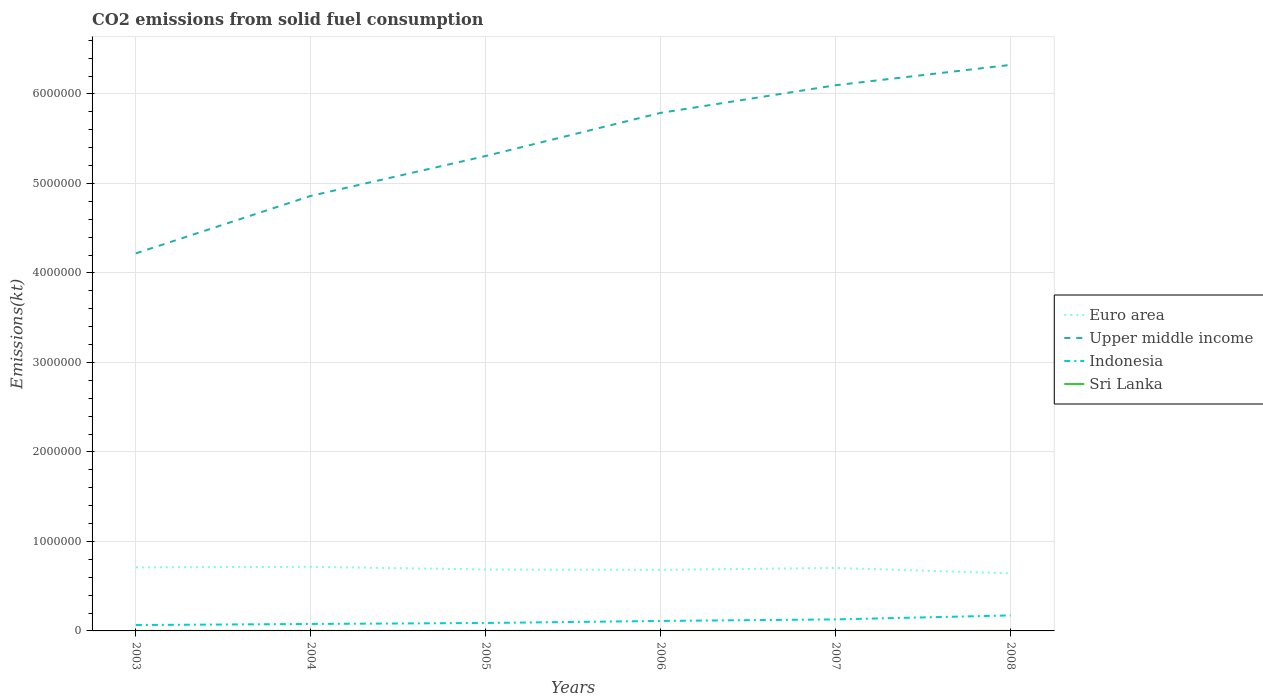How many different coloured lines are there?
Keep it short and to the point. 4. Across all years, what is the maximum amount of CO2 emitted in Indonesia?
Provide a succinct answer. 6.58e+04. In which year was the amount of CO2 emitted in Sri Lanka maximum?
Offer a very short reply. 2007. What is the total amount of CO2 emitted in Sri Lanka in the graph?
Your answer should be very brief. 0. What is the difference between the highest and the second highest amount of CO2 emitted in Euro area?
Make the answer very short. 7.28e+04. What is the difference between the highest and the lowest amount of CO2 emitted in Euro area?
Offer a terse response. 3. How many lines are there?
Provide a succinct answer. 4. Does the graph contain any zero values?
Make the answer very short. No. Does the graph contain grids?
Keep it short and to the point. Yes. Where does the legend appear in the graph?
Keep it short and to the point. Center right. How are the legend labels stacked?
Your answer should be compact. Vertical. What is the title of the graph?
Offer a terse response. CO2 emissions from solid fuel consumption. Does "Iran" appear as one of the legend labels in the graph?
Offer a terse response. No. What is the label or title of the X-axis?
Your answer should be very brief. Years. What is the label or title of the Y-axis?
Your answer should be compact. Emissions(kt). What is the Emissions(kt) of Euro area in 2003?
Give a very brief answer. 7.10e+05. What is the Emissions(kt) of Upper middle income in 2003?
Ensure brevity in your answer.  4.22e+06. What is the Emissions(kt) in Indonesia in 2003?
Your response must be concise. 6.58e+04. What is the Emissions(kt) of Sri Lanka in 2003?
Provide a succinct answer. 231.02. What is the Emissions(kt) in Euro area in 2004?
Provide a succinct answer. 7.16e+05. What is the Emissions(kt) of Upper middle income in 2004?
Provide a short and direct response. 4.86e+06. What is the Emissions(kt) of Indonesia in 2004?
Offer a very short reply. 7.77e+04. What is the Emissions(kt) in Sri Lanka in 2004?
Make the answer very short. 231.02. What is the Emissions(kt) of Euro area in 2005?
Offer a very short reply. 6.86e+05. What is the Emissions(kt) of Upper middle income in 2005?
Provide a succinct answer. 5.31e+06. What is the Emissions(kt) of Indonesia in 2005?
Ensure brevity in your answer.  8.86e+04. What is the Emissions(kt) in Sri Lanka in 2005?
Ensure brevity in your answer.  231.02. What is the Emissions(kt) of Euro area in 2006?
Offer a very short reply. 6.82e+05. What is the Emissions(kt) in Upper middle income in 2006?
Offer a terse response. 5.79e+06. What is the Emissions(kt) in Indonesia in 2006?
Offer a very short reply. 1.11e+05. What is the Emissions(kt) of Sri Lanka in 2006?
Keep it short and to the point. 227.35. What is the Emissions(kt) of Euro area in 2007?
Offer a terse response. 7.04e+05. What is the Emissions(kt) of Upper middle income in 2007?
Your response must be concise. 6.10e+06. What is the Emissions(kt) in Indonesia in 2007?
Your response must be concise. 1.29e+05. What is the Emissions(kt) of Sri Lanka in 2007?
Your response must be concise. 161.35. What is the Emissions(kt) of Euro area in 2008?
Make the answer very short. 6.44e+05. What is the Emissions(kt) in Upper middle income in 2008?
Make the answer very short. 6.32e+06. What is the Emissions(kt) of Indonesia in 2008?
Ensure brevity in your answer.  1.73e+05. What is the Emissions(kt) of Sri Lanka in 2008?
Ensure brevity in your answer.  220.02. Across all years, what is the maximum Emissions(kt) of Euro area?
Your answer should be very brief. 7.16e+05. Across all years, what is the maximum Emissions(kt) in Upper middle income?
Your response must be concise. 6.32e+06. Across all years, what is the maximum Emissions(kt) of Indonesia?
Offer a terse response. 1.73e+05. Across all years, what is the maximum Emissions(kt) of Sri Lanka?
Give a very brief answer. 231.02. Across all years, what is the minimum Emissions(kt) in Euro area?
Your answer should be very brief. 6.44e+05. Across all years, what is the minimum Emissions(kt) in Upper middle income?
Offer a terse response. 4.22e+06. Across all years, what is the minimum Emissions(kt) of Indonesia?
Your answer should be compact. 6.58e+04. Across all years, what is the minimum Emissions(kt) in Sri Lanka?
Make the answer very short. 161.35. What is the total Emissions(kt) in Euro area in the graph?
Keep it short and to the point. 4.14e+06. What is the total Emissions(kt) in Upper middle income in the graph?
Offer a terse response. 3.26e+07. What is the total Emissions(kt) in Indonesia in the graph?
Your answer should be very brief. 6.46e+05. What is the total Emissions(kt) of Sri Lanka in the graph?
Your answer should be compact. 1301.79. What is the difference between the Emissions(kt) of Euro area in 2003 and that in 2004?
Your response must be concise. -6039.27. What is the difference between the Emissions(kt) in Upper middle income in 2003 and that in 2004?
Offer a terse response. -6.42e+05. What is the difference between the Emissions(kt) of Indonesia in 2003 and that in 2004?
Offer a terse response. -1.20e+04. What is the difference between the Emissions(kt) in Euro area in 2003 and that in 2005?
Offer a terse response. 2.40e+04. What is the difference between the Emissions(kt) of Upper middle income in 2003 and that in 2005?
Your answer should be very brief. -1.09e+06. What is the difference between the Emissions(kt) of Indonesia in 2003 and that in 2005?
Provide a short and direct response. -2.29e+04. What is the difference between the Emissions(kt) in Sri Lanka in 2003 and that in 2005?
Offer a terse response. 0. What is the difference between the Emissions(kt) in Euro area in 2003 and that in 2006?
Provide a short and direct response. 2.78e+04. What is the difference between the Emissions(kt) of Upper middle income in 2003 and that in 2006?
Keep it short and to the point. -1.57e+06. What is the difference between the Emissions(kt) of Indonesia in 2003 and that in 2006?
Give a very brief answer. -4.57e+04. What is the difference between the Emissions(kt) in Sri Lanka in 2003 and that in 2006?
Give a very brief answer. 3.67. What is the difference between the Emissions(kt) in Euro area in 2003 and that in 2007?
Offer a very short reply. 6607.98. What is the difference between the Emissions(kt) of Upper middle income in 2003 and that in 2007?
Keep it short and to the point. -1.88e+06. What is the difference between the Emissions(kt) of Indonesia in 2003 and that in 2007?
Provide a succinct answer. -6.30e+04. What is the difference between the Emissions(kt) in Sri Lanka in 2003 and that in 2007?
Keep it short and to the point. 69.67. What is the difference between the Emissions(kt) of Euro area in 2003 and that in 2008?
Provide a succinct answer. 6.67e+04. What is the difference between the Emissions(kt) of Upper middle income in 2003 and that in 2008?
Ensure brevity in your answer.  -2.11e+06. What is the difference between the Emissions(kt) in Indonesia in 2003 and that in 2008?
Provide a succinct answer. -1.07e+05. What is the difference between the Emissions(kt) in Sri Lanka in 2003 and that in 2008?
Offer a very short reply. 11. What is the difference between the Emissions(kt) of Euro area in 2004 and that in 2005?
Give a very brief answer. 3.00e+04. What is the difference between the Emissions(kt) of Upper middle income in 2004 and that in 2005?
Your answer should be very brief. -4.45e+05. What is the difference between the Emissions(kt) of Indonesia in 2004 and that in 2005?
Keep it short and to the point. -1.09e+04. What is the difference between the Emissions(kt) of Euro area in 2004 and that in 2006?
Offer a very short reply. 3.39e+04. What is the difference between the Emissions(kt) of Upper middle income in 2004 and that in 2006?
Offer a very short reply. -9.28e+05. What is the difference between the Emissions(kt) in Indonesia in 2004 and that in 2006?
Offer a very short reply. -3.37e+04. What is the difference between the Emissions(kt) in Sri Lanka in 2004 and that in 2006?
Keep it short and to the point. 3.67. What is the difference between the Emissions(kt) of Euro area in 2004 and that in 2007?
Provide a succinct answer. 1.26e+04. What is the difference between the Emissions(kt) in Upper middle income in 2004 and that in 2007?
Offer a very short reply. -1.24e+06. What is the difference between the Emissions(kt) in Indonesia in 2004 and that in 2007?
Provide a succinct answer. -5.10e+04. What is the difference between the Emissions(kt) in Sri Lanka in 2004 and that in 2007?
Give a very brief answer. 69.67. What is the difference between the Emissions(kt) of Euro area in 2004 and that in 2008?
Offer a very short reply. 7.28e+04. What is the difference between the Emissions(kt) in Upper middle income in 2004 and that in 2008?
Your answer should be compact. -1.46e+06. What is the difference between the Emissions(kt) of Indonesia in 2004 and that in 2008?
Your response must be concise. -9.55e+04. What is the difference between the Emissions(kt) in Sri Lanka in 2004 and that in 2008?
Ensure brevity in your answer.  11. What is the difference between the Emissions(kt) in Euro area in 2005 and that in 2006?
Give a very brief answer. 3892.87. What is the difference between the Emissions(kt) in Upper middle income in 2005 and that in 2006?
Your answer should be very brief. -4.82e+05. What is the difference between the Emissions(kt) of Indonesia in 2005 and that in 2006?
Make the answer very short. -2.28e+04. What is the difference between the Emissions(kt) in Sri Lanka in 2005 and that in 2006?
Provide a short and direct response. 3.67. What is the difference between the Emissions(kt) in Euro area in 2005 and that in 2007?
Your answer should be compact. -1.73e+04. What is the difference between the Emissions(kt) in Upper middle income in 2005 and that in 2007?
Give a very brief answer. -7.91e+05. What is the difference between the Emissions(kt) of Indonesia in 2005 and that in 2007?
Keep it short and to the point. -4.01e+04. What is the difference between the Emissions(kt) in Sri Lanka in 2005 and that in 2007?
Offer a very short reply. 69.67. What is the difference between the Emissions(kt) of Euro area in 2005 and that in 2008?
Ensure brevity in your answer.  4.28e+04. What is the difference between the Emissions(kt) of Upper middle income in 2005 and that in 2008?
Offer a terse response. -1.02e+06. What is the difference between the Emissions(kt) of Indonesia in 2005 and that in 2008?
Ensure brevity in your answer.  -8.46e+04. What is the difference between the Emissions(kt) in Sri Lanka in 2005 and that in 2008?
Your response must be concise. 11. What is the difference between the Emissions(kt) of Euro area in 2006 and that in 2007?
Your response must be concise. -2.12e+04. What is the difference between the Emissions(kt) in Upper middle income in 2006 and that in 2007?
Your answer should be compact. -3.08e+05. What is the difference between the Emissions(kt) of Indonesia in 2006 and that in 2007?
Ensure brevity in your answer.  -1.73e+04. What is the difference between the Emissions(kt) in Sri Lanka in 2006 and that in 2007?
Make the answer very short. 66.01. What is the difference between the Emissions(kt) in Euro area in 2006 and that in 2008?
Give a very brief answer. 3.89e+04. What is the difference between the Emissions(kt) of Upper middle income in 2006 and that in 2008?
Give a very brief answer. -5.36e+05. What is the difference between the Emissions(kt) of Indonesia in 2006 and that in 2008?
Give a very brief answer. -6.18e+04. What is the difference between the Emissions(kt) in Sri Lanka in 2006 and that in 2008?
Provide a succinct answer. 7.33. What is the difference between the Emissions(kt) of Euro area in 2007 and that in 2008?
Make the answer very short. 6.01e+04. What is the difference between the Emissions(kt) in Upper middle income in 2007 and that in 2008?
Provide a short and direct response. -2.28e+05. What is the difference between the Emissions(kt) of Indonesia in 2007 and that in 2008?
Your answer should be compact. -4.45e+04. What is the difference between the Emissions(kt) in Sri Lanka in 2007 and that in 2008?
Ensure brevity in your answer.  -58.67. What is the difference between the Emissions(kt) in Euro area in 2003 and the Emissions(kt) in Upper middle income in 2004?
Your response must be concise. -4.15e+06. What is the difference between the Emissions(kt) of Euro area in 2003 and the Emissions(kt) of Indonesia in 2004?
Your response must be concise. 6.33e+05. What is the difference between the Emissions(kt) in Euro area in 2003 and the Emissions(kt) in Sri Lanka in 2004?
Give a very brief answer. 7.10e+05. What is the difference between the Emissions(kt) of Upper middle income in 2003 and the Emissions(kt) of Indonesia in 2004?
Your answer should be compact. 4.14e+06. What is the difference between the Emissions(kt) of Upper middle income in 2003 and the Emissions(kt) of Sri Lanka in 2004?
Your answer should be compact. 4.22e+06. What is the difference between the Emissions(kt) of Indonesia in 2003 and the Emissions(kt) of Sri Lanka in 2004?
Provide a short and direct response. 6.55e+04. What is the difference between the Emissions(kt) in Euro area in 2003 and the Emissions(kt) in Upper middle income in 2005?
Your answer should be compact. -4.60e+06. What is the difference between the Emissions(kt) in Euro area in 2003 and the Emissions(kt) in Indonesia in 2005?
Offer a very short reply. 6.22e+05. What is the difference between the Emissions(kt) in Euro area in 2003 and the Emissions(kt) in Sri Lanka in 2005?
Your answer should be very brief. 7.10e+05. What is the difference between the Emissions(kt) of Upper middle income in 2003 and the Emissions(kt) of Indonesia in 2005?
Ensure brevity in your answer.  4.13e+06. What is the difference between the Emissions(kt) in Upper middle income in 2003 and the Emissions(kt) in Sri Lanka in 2005?
Provide a short and direct response. 4.22e+06. What is the difference between the Emissions(kt) in Indonesia in 2003 and the Emissions(kt) in Sri Lanka in 2005?
Offer a very short reply. 6.55e+04. What is the difference between the Emissions(kt) in Euro area in 2003 and the Emissions(kt) in Upper middle income in 2006?
Give a very brief answer. -5.08e+06. What is the difference between the Emissions(kt) in Euro area in 2003 and the Emissions(kt) in Indonesia in 2006?
Your answer should be compact. 5.99e+05. What is the difference between the Emissions(kt) in Euro area in 2003 and the Emissions(kt) in Sri Lanka in 2006?
Your response must be concise. 7.10e+05. What is the difference between the Emissions(kt) of Upper middle income in 2003 and the Emissions(kt) of Indonesia in 2006?
Your answer should be very brief. 4.11e+06. What is the difference between the Emissions(kt) of Upper middle income in 2003 and the Emissions(kt) of Sri Lanka in 2006?
Your response must be concise. 4.22e+06. What is the difference between the Emissions(kt) in Indonesia in 2003 and the Emissions(kt) in Sri Lanka in 2006?
Make the answer very short. 6.55e+04. What is the difference between the Emissions(kt) in Euro area in 2003 and the Emissions(kt) in Upper middle income in 2007?
Ensure brevity in your answer.  -5.39e+06. What is the difference between the Emissions(kt) in Euro area in 2003 and the Emissions(kt) in Indonesia in 2007?
Keep it short and to the point. 5.81e+05. What is the difference between the Emissions(kt) of Euro area in 2003 and the Emissions(kt) of Sri Lanka in 2007?
Keep it short and to the point. 7.10e+05. What is the difference between the Emissions(kt) in Upper middle income in 2003 and the Emissions(kt) in Indonesia in 2007?
Offer a terse response. 4.09e+06. What is the difference between the Emissions(kt) in Upper middle income in 2003 and the Emissions(kt) in Sri Lanka in 2007?
Provide a short and direct response. 4.22e+06. What is the difference between the Emissions(kt) of Indonesia in 2003 and the Emissions(kt) of Sri Lanka in 2007?
Ensure brevity in your answer.  6.56e+04. What is the difference between the Emissions(kt) in Euro area in 2003 and the Emissions(kt) in Upper middle income in 2008?
Provide a succinct answer. -5.61e+06. What is the difference between the Emissions(kt) in Euro area in 2003 and the Emissions(kt) in Indonesia in 2008?
Offer a very short reply. 5.37e+05. What is the difference between the Emissions(kt) of Euro area in 2003 and the Emissions(kt) of Sri Lanka in 2008?
Give a very brief answer. 7.10e+05. What is the difference between the Emissions(kt) in Upper middle income in 2003 and the Emissions(kt) in Indonesia in 2008?
Keep it short and to the point. 4.05e+06. What is the difference between the Emissions(kt) in Upper middle income in 2003 and the Emissions(kt) in Sri Lanka in 2008?
Offer a terse response. 4.22e+06. What is the difference between the Emissions(kt) of Indonesia in 2003 and the Emissions(kt) of Sri Lanka in 2008?
Provide a succinct answer. 6.55e+04. What is the difference between the Emissions(kt) of Euro area in 2004 and the Emissions(kt) of Upper middle income in 2005?
Give a very brief answer. -4.59e+06. What is the difference between the Emissions(kt) of Euro area in 2004 and the Emissions(kt) of Indonesia in 2005?
Make the answer very short. 6.28e+05. What is the difference between the Emissions(kt) in Euro area in 2004 and the Emissions(kt) in Sri Lanka in 2005?
Your answer should be very brief. 7.16e+05. What is the difference between the Emissions(kt) of Upper middle income in 2004 and the Emissions(kt) of Indonesia in 2005?
Offer a very short reply. 4.77e+06. What is the difference between the Emissions(kt) in Upper middle income in 2004 and the Emissions(kt) in Sri Lanka in 2005?
Offer a terse response. 4.86e+06. What is the difference between the Emissions(kt) of Indonesia in 2004 and the Emissions(kt) of Sri Lanka in 2005?
Make the answer very short. 7.75e+04. What is the difference between the Emissions(kt) in Euro area in 2004 and the Emissions(kt) in Upper middle income in 2006?
Offer a terse response. -5.07e+06. What is the difference between the Emissions(kt) in Euro area in 2004 and the Emissions(kt) in Indonesia in 2006?
Keep it short and to the point. 6.05e+05. What is the difference between the Emissions(kt) of Euro area in 2004 and the Emissions(kt) of Sri Lanka in 2006?
Provide a short and direct response. 7.16e+05. What is the difference between the Emissions(kt) of Upper middle income in 2004 and the Emissions(kt) of Indonesia in 2006?
Your answer should be very brief. 4.75e+06. What is the difference between the Emissions(kt) in Upper middle income in 2004 and the Emissions(kt) in Sri Lanka in 2006?
Provide a short and direct response. 4.86e+06. What is the difference between the Emissions(kt) in Indonesia in 2004 and the Emissions(kt) in Sri Lanka in 2006?
Offer a terse response. 7.75e+04. What is the difference between the Emissions(kt) in Euro area in 2004 and the Emissions(kt) in Upper middle income in 2007?
Your answer should be compact. -5.38e+06. What is the difference between the Emissions(kt) of Euro area in 2004 and the Emissions(kt) of Indonesia in 2007?
Make the answer very short. 5.88e+05. What is the difference between the Emissions(kt) in Euro area in 2004 and the Emissions(kt) in Sri Lanka in 2007?
Your answer should be compact. 7.16e+05. What is the difference between the Emissions(kt) of Upper middle income in 2004 and the Emissions(kt) of Indonesia in 2007?
Your response must be concise. 4.73e+06. What is the difference between the Emissions(kt) in Upper middle income in 2004 and the Emissions(kt) in Sri Lanka in 2007?
Your answer should be very brief. 4.86e+06. What is the difference between the Emissions(kt) of Indonesia in 2004 and the Emissions(kt) of Sri Lanka in 2007?
Provide a short and direct response. 7.76e+04. What is the difference between the Emissions(kt) in Euro area in 2004 and the Emissions(kt) in Upper middle income in 2008?
Keep it short and to the point. -5.61e+06. What is the difference between the Emissions(kt) in Euro area in 2004 and the Emissions(kt) in Indonesia in 2008?
Give a very brief answer. 5.43e+05. What is the difference between the Emissions(kt) in Euro area in 2004 and the Emissions(kt) in Sri Lanka in 2008?
Offer a very short reply. 7.16e+05. What is the difference between the Emissions(kt) of Upper middle income in 2004 and the Emissions(kt) of Indonesia in 2008?
Make the answer very short. 4.69e+06. What is the difference between the Emissions(kt) of Upper middle income in 2004 and the Emissions(kt) of Sri Lanka in 2008?
Provide a short and direct response. 4.86e+06. What is the difference between the Emissions(kt) of Indonesia in 2004 and the Emissions(kt) of Sri Lanka in 2008?
Offer a very short reply. 7.75e+04. What is the difference between the Emissions(kt) in Euro area in 2005 and the Emissions(kt) in Upper middle income in 2006?
Your response must be concise. -5.10e+06. What is the difference between the Emissions(kt) in Euro area in 2005 and the Emissions(kt) in Indonesia in 2006?
Your response must be concise. 5.75e+05. What is the difference between the Emissions(kt) of Euro area in 2005 and the Emissions(kt) of Sri Lanka in 2006?
Give a very brief answer. 6.86e+05. What is the difference between the Emissions(kt) in Upper middle income in 2005 and the Emissions(kt) in Indonesia in 2006?
Provide a succinct answer. 5.19e+06. What is the difference between the Emissions(kt) in Upper middle income in 2005 and the Emissions(kt) in Sri Lanka in 2006?
Provide a succinct answer. 5.31e+06. What is the difference between the Emissions(kt) of Indonesia in 2005 and the Emissions(kt) of Sri Lanka in 2006?
Make the answer very short. 8.84e+04. What is the difference between the Emissions(kt) of Euro area in 2005 and the Emissions(kt) of Upper middle income in 2007?
Offer a very short reply. -5.41e+06. What is the difference between the Emissions(kt) of Euro area in 2005 and the Emissions(kt) of Indonesia in 2007?
Your answer should be compact. 5.58e+05. What is the difference between the Emissions(kt) of Euro area in 2005 and the Emissions(kt) of Sri Lanka in 2007?
Your answer should be compact. 6.86e+05. What is the difference between the Emissions(kt) of Upper middle income in 2005 and the Emissions(kt) of Indonesia in 2007?
Keep it short and to the point. 5.18e+06. What is the difference between the Emissions(kt) in Upper middle income in 2005 and the Emissions(kt) in Sri Lanka in 2007?
Make the answer very short. 5.31e+06. What is the difference between the Emissions(kt) of Indonesia in 2005 and the Emissions(kt) of Sri Lanka in 2007?
Make the answer very short. 8.85e+04. What is the difference between the Emissions(kt) of Euro area in 2005 and the Emissions(kt) of Upper middle income in 2008?
Make the answer very short. -5.64e+06. What is the difference between the Emissions(kt) in Euro area in 2005 and the Emissions(kt) in Indonesia in 2008?
Your answer should be very brief. 5.13e+05. What is the difference between the Emissions(kt) in Euro area in 2005 and the Emissions(kt) in Sri Lanka in 2008?
Offer a very short reply. 6.86e+05. What is the difference between the Emissions(kt) of Upper middle income in 2005 and the Emissions(kt) of Indonesia in 2008?
Make the answer very short. 5.13e+06. What is the difference between the Emissions(kt) of Upper middle income in 2005 and the Emissions(kt) of Sri Lanka in 2008?
Provide a succinct answer. 5.31e+06. What is the difference between the Emissions(kt) in Indonesia in 2005 and the Emissions(kt) in Sri Lanka in 2008?
Offer a terse response. 8.84e+04. What is the difference between the Emissions(kt) in Euro area in 2006 and the Emissions(kt) in Upper middle income in 2007?
Keep it short and to the point. -5.41e+06. What is the difference between the Emissions(kt) in Euro area in 2006 and the Emissions(kt) in Indonesia in 2007?
Offer a terse response. 5.54e+05. What is the difference between the Emissions(kt) of Euro area in 2006 and the Emissions(kt) of Sri Lanka in 2007?
Keep it short and to the point. 6.82e+05. What is the difference between the Emissions(kt) of Upper middle income in 2006 and the Emissions(kt) of Indonesia in 2007?
Your answer should be very brief. 5.66e+06. What is the difference between the Emissions(kt) of Upper middle income in 2006 and the Emissions(kt) of Sri Lanka in 2007?
Ensure brevity in your answer.  5.79e+06. What is the difference between the Emissions(kt) of Indonesia in 2006 and the Emissions(kt) of Sri Lanka in 2007?
Your answer should be very brief. 1.11e+05. What is the difference between the Emissions(kt) in Euro area in 2006 and the Emissions(kt) in Upper middle income in 2008?
Your response must be concise. -5.64e+06. What is the difference between the Emissions(kt) in Euro area in 2006 and the Emissions(kt) in Indonesia in 2008?
Keep it short and to the point. 5.09e+05. What is the difference between the Emissions(kt) of Euro area in 2006 and the Emissions(kt) of Sri Lanka in 2008?
Provide a short and direct response. 6.82e+05. What is the difference between the Emissions(kt) in Upper middle income in 2006 and the Emissions(kt) in Indonesia in 2008?
Provide a short and direct response. 5.61e+06. What is the difference between the Emissions(kt) of Upper middle income in 2006 and the Emissions(kt) of Sri Lanka in 2008?
Your answer should be very brief. 5.79e+06. What is the difference between the Emissions(kt) of Indonesia in 2006 and the Emissions(kt) of Sri Lanka in 2008?
Your response must be concise. 1.11e+05. What is the difference between the Emissions(kt) of Euro area in 2007 and the Emissions(kt) of Upper middle income in 2008?
Offer a terse response. -5.62e+06. What is the difference between the Emissions(kt) in Euro area in 2007 and the Emissions(kt) in Indonesia in 2008?
Offer a terse response. 5.30e+05. What is the difference between the Emissions(kt) in Euro area in 2007 and the Emissions(kt) in Sri Lanka in 2008?
Keep it short and to the point. 7.03e+05. What is the difference between the Emissions(kt) in Upper middle income in 2007 and the Emissions(kt) in Indonesia in 2008?
Provide a succinct answer. 5.92e+06. What is the difference between the Emissions(kt) of Upper middle income in 2007 and the Emissions(kt) of Sri Lanka in 2008?
Your response must be concise. 6.10e+06. What is the difference between the Emissions(kt) of Indonesia in 2007 and the Emissions(kt) of Sri Lanka in 2008?
Give a very brief answer. 1.29e+05. What is the average Emissions(kt) in Euro area per year?
Your response must be concise. 6.90e+05. What is the average Emissions(kt) in Upper middle income per year?
Your response must be concise. 5.43e+06. What is the average Emissions(kt) of Indonesia per year?
Your response must be concise. 1.08e+05. What is the average Emissions(kt) of Sri Lanka per year?
Your answer should be very brief. 216.96. In the year 2003, what is the difference between the Emissions(kt) in Euro area and Emissions(kt) in Upper middle income?
Your answer should be compact. -3.51e+06. In the year 2003, what is the difference between the Emissions(kt) of Euro area and Emissions(kt) of Indonesia?
Provide a succinct answer. 6.45e+05. In the year 2003, what is the difference between the Emissions(kt) in Euro area and Emissions(kt) in Sri Lanka?
Provide a succinct answer. 7.10e+05. In the year 2003, what is the difference between the Emissions(kt) of Upper middle income and Emissions(kt) of Indonesia?
Your answer should be very brief. 4.15e+06. In the year 2003, what is the difference between the Emissions(kt) of Upper middle income and Emissions(kt) of Sri Lanka?
Your answer should be compact. 4.22e+06. In the year 2003, what is the difference between the Emissions(kt) in Indonesia and Emissions(kt) in Sri Lanka?
Your answer should be very brief. 6.55e+04. In the year 2004, what is the difference between the Emissions(kt) of Euro area and Emissions(kt) of Upper middle income?
Provide a short and direct response. -4.14e+06. In the year 2004, what is the difference between the Emissions(kt) of Euro area and Emissions(kt) of Indonesia?
Offer a very short reply. 6.39e+05. In the year 2004, what is the difference between the Emissions(kt) of Euro area and Emissions(kt) of Sri Lanka?
Keep it short and to the point. 7.16e+05. In the year 2004, what is the difference between the Emissions(kt) of Upper middle income and Emissions(kt) of Indonesia?
Make the answer very short. 4.78e+06. In the year 2004, what is the difference between the Emissions(kt) of Upper middle income and Emissions(kt) of Sri Lanka?
Your response must be concise. 4.86e+06. In the year 2004, what is the difference between the Emissions(kt) of Indonesia and Emissions(kt) of Sri Lanka?
Provide a succinct answer. 7.75e+04. In the year 2005, what is the difference between the Emissions(kt) of Euro area and Emissions(kt) of Upper middle income?
Provide a short and direct response. -4.62e+06. In the year 2005, what is the difference between the Emissions(kt) in Euro area and Emissions(kt) in Indonesia?
Make the answer very short. 5.98e+05. In the year 2005, what is the difference between the Emissions(kt) of Euro area and Emissions(kt) of Sri Lanka?
Give a very brief answer. 6.86e+05. In the year 2005, what is the difference between the Emissions(kt) in Upper middle income and Emissions(kt) in Indonesia?
Your answer should be very brief. 5.22e+06. In the year 2005, what is the difference between the Emissions(kt) of Upper middle income and Emissions(kt) of Sri Lanka?
Offer a very short reply. 5.31e+06. In the year 2005, what is the difference between the Emissions(kt) of Indonesia and Emissions(kt) of Sri Lanka?
Provide a succinct answer. 8.84e+04. In the year 2006, what is the difference between the Emissions(kt) in Euro area and Emissions(kt) in Upper middle income?
Provide a short and direct response. -5.11e+06. In the year 2006, what is the difference between the Emissions(kt) in Euro area and Emissions(kt) in Indonesia?
Your response must be concise. 5.71e+05. In the year 2006, what is the difference between the Emissions(kt) in Euro area and Emissions(kt) in Sri Lanka?
Provide a succinct answer. 6.82e+05. In the year 2006, what is the difference between the Emissions(kt) of Upper middle income and Emissions(kt) of Indonesia?
Give a very brief answer. 5.68e+06. In the year 2006, what is the difference between the Emissions(kt) of Upper middle income and Emissions(kt) of Sri Lanka?
Provide a short and direct response. 5.79e+06. In the year 2006, what is the difference between the Emissions(kt) in Indonesia and Emissions(kt) in Sri Lanka?
Make the answer very short. 1.11e+05. In the year 2007, what is the difference between the Emissions(kt) of Euro area and Emissions(kt) of Upper middle income?
Ensure brevity in your answer.  -5.39e+06. In the year 2007, what is the difference between the Emissions(kt) in Euro area and Emissions(kt) in Indonesia?
Offer a terse response. 5.75e+05. In the year 2007, what is the difference between the Emissions(kt) of Euro area and Emissions(kt) of Sri Lanka?
Provide a short and direct response. 7.03e+05. In the year 2007, what is the difference between the Emissions(kt) in Upper middle income and Emissions(kt) in Indonesia?
Provide a short and direct response. 5.97e+06. In the year 2007, what is the difference between the Emissions(kt) of Upper middle income and Emissions(kt) of Sri Lanka?
Give a very brief answer. 6.10e+06. In the year 2007, what is the difference between the Emissions(kt) in Indonesia and Emissions(kt) in Sri Lanka?
Give a very brief answer. 1.29e+05. In the year 2008, what is the difference between the Emissions(kt) in Euro area and Emissions(kt) in Upper middle income?
Your response must be concise. -5.68e+06. In the year 2008, what is the difference between the Emissions(kt) in Euro area and Emissions(kt) in Indonesia?
Offer a very short reply. 4.70e+05. In the year 2008, what is the difference between the Emissions(kt) of Euro area and Emissions(kt) of Sri Lanka?
Keep it short and to the point. 6.43e+05. In the year 2008, what is the difference between the Emissions(kt) of Upper middle income and Emissions(kt) of Indonesia?
Ensure brevity in your answer.  6.15e+06. In the year 2008, what is the difference between the Emissions(kt) of Upper middle income and Emissions(kt) of Sri Lanka?
Your answer should be compact. 6.32e+06. In the year 2008, what is the difference between the Emissions(kt) in Indonesia and Emissions(kt) in Sri Lanka?
Give a very brief answer. 1.73e+05. What is the ratio of the Emissions(kt) in Upper middle income in 2003 to that in 2004?
Your response must be concise. 0.87. What is the ratio of the Emissions(kt) of Indonesia in 2003 to that in 2004?
Your answer should be compact. 0.85. What is the ratio of the Emissions(kt) in Sri Lanka in 2003 to that in 2004?
Make the answer very short. 1. What is the ratio of the Emissions(kt) in Euro area in 2003 to that in 2005?
Provide a succinct answer. 1.03. What is the ratio of the Emissions(kt) in Upper middle income in 2003 to that in 2005?
Provide a succinct answer. 0.8. What is the ratio of the Emissions(kt) of Indonesia in 2003 to that in 2005?
Provide a succinct answer. 0.74. What is the ratio of the Emissions(kt) in Sri Lanka in 2003 to that in 2005?
Give a very brief answer. 1. What is the ratio of the Emissions(kt) in Euro area in 2003 to that in 2006?
Your answer should be compact. 1.04. What is the ratio of the Emissions(kt) of Upper middle income in 2003 to that in 2006?
Your answer should be compact. 0.73. What is the ratio of the Emissions(kt) of Indonesia in 2003 to that in 2006?
Ensure brevity in your answer.  0.59. What is the ratio of the Emissions(kt) in Sri Lanka in 2003 to that in 2006?
Provide a short and direct response. 1.02. What is the ratio of the Emissions(kt) of Euro area in 2003 to that in 2007?
Offer a very short reply. 1.01. What is the ratio of the Emissions(kt) of Upper middle income in 2003 to that in 2007?
Your answer should be compact. 0.69. What is the ratio of the Emissions(kt) in Indonesia in 2003 to that in 2007?
Ensure brevity in your answer.  0.51. What is the ratio of the Emissions(kt) of Sri Lanka in 2003 to that in 2007?
Offer a terse response. 1.43. What is the ratio of the Emissions(kt) in Euro area in 2003 to that in 2008?
Offer a very short reply. 1.1. What is the ratio of the Emissions(kt) of Upper middle income in 2003 to that in 2008?
Your answer should be compact. 0.67. What is the ratio of the Emissions(kt) of Indonesia in 2003 to that in 2008?
Ensure brevity in your answer.  0.38. What is the ratio of the Emissions(kt) in Euro area in 2004 to that in 2005?
Offer a terse response. 1.04. What is the ratio of the Emissions(kt) of Upper middle income in 2004 to that in 2005?
Offer a terse response. 0.92. What is the ratio of the Emissions(kt) in Indonesia in 2004 to that in 2005?
Offer a terse response. 0.88. What is the ratio of the Emissions(kt) of Sri Lanka in 2004 to that in 2005?
Your answer should be compact. 1. What is the ratio of the Emissions(kt) of Euro area in 2004 to that in 2006?
Offer a very short reply. 1.05. What is the ratio of the Emissions(kt) in Upper middle income in 2004 to that in 2006?
Give a very brief answer. 0.84. What is the ratio of the Emissions(kt) in Indonesia in 2004 to that in 2006?
Keep it short and to the point. 0.7. What is the ratio of the Emissions(kt) in Sri Lanka in 2004 to that in 2006?
Make the answer very short. 1.02. What is the ratio of the Emissions(kt) of Euro area in 2004 to that in 2007?
Make the answer very short. 1.02. What is the ratio of the Emissions(kt) in Upper middle income in 2004 to that in 2007?
Your answer should be very brief. 0.8. What is the ratio of the Emissions(kt) in Indonesia in 2004 to that in 2007?
Offer a very short reply. 0.6. What is the ratio of the Emissions(kt) of Sri Lanka in 2004 to that in 2007?
Your response must be concise. 1.43. What is the ratio of the Emissions(kt) in Euro area in 2004 to that in 2008?
Your answer should be compact. 1.11. What is the ratio of the Emissions(kt) in Upper middle income in 2004 to that in 2008?
Ensure brevity in your answer.  0.77. What is the ratio of the Emissions(kt) of Indonesia in 2004 to that in 2008?
Your answer should be very brief. 0.45. What is the ratio of the Emissions(kt) in Sri Lanka in 2004 to that in 2008?
Keep it short and to the point. 1.05. What is the ratio of the Emissions(kt) in Upper middle income in 2005 to that in 2006?
Provide a short and direct response. 0.92. What is the ratio of the Emissions(kt) of Indonesia in 2005 to that in 2006?
Ensure brevity in your answer.  0.8. What is the ratio of the Emissions(kt) of Sri Lanka in 2005 to that in 2006?
Your answer should be compact. 1.02. What is the ratio of the Emissions(kt) of Euro area in 2005 to that in 2007?
Make the answer very short. 0.98. What is the ratio of the Emissions(kt) in Upper middle income in 2005 to that in 2007?
Your response must be concise. 0.87. What is the ratio of the Emissions(kt) of Indonesia in 2005 to that in 2007?
Your answer should be compact. 0.69. What is the ratio of the Emissions(kt) in Sri Lanka in 2005 to that in 2007?
Provide a short and direct response. 1.43. What is the ratio of the Emissions(kt) of Euro area in 2005 to that in 2008?
Keep it short and to the point. 1.07. What is the ratio of the Emissions(kt) of Upper middle income in 2005 to that in 2008?
Provide a succinct answer. 0.84. What is the ratio of the Emissions(kt) of Indonesia in 2005 to that in 2008?
Your response must be concise. 0.51. What is the ratio of the Emissions(kt) of Sri Lanka in 2005 to that in 2008?
Ensure brevity in your answer.  1.05. What is the ratio of the Emissions(kt) of Euro area in 2006 to that in 2007?
Offer a very short reply. 0.97. What is the ratio of the Emissions(kt) of Upper middle income in 2006 to that in 2007?
Keep it short and to the point. 0.95. What is the ratio of the Emissions(kt) of Indonesia in 2006 to that in 2007?
Make the answer very short. 0.87. What is the ratio of the Emissions(kt) of Sri Lanka in 2006 to that in 2007?
Your answer should be very brief. 1.41. What is the ratio of the Emissions(kt) of Euro area in 2006 to that in 2008?
Ensure brevity in your answer.  1.06. What is the ratio of the Emissions(kt) of Upper middle income in 2006 to that in 2008?
Your response must be concise. 0.92. What is the ratio of the Emissions(kt) of Indonesia in 2006 to that in 2008?
Ensure brevity in your answer.  0.64. What is the ratio of the Emissions(kt) of Euro area in 2007 to that in 2008?
Keep it short and to the point. 1.09. What is the ratio of the Emissions(kt) in Upper middle income in 2007 to that in 2008?
Give a very brief answer. 0.96. What is the ratio of the Emissions(kt) in Indonesia in 2007 to that in 2008?
Offer a terse response. 0.74. What is the ratio of the Emissions(kt) of Sri Lanka in 2007 to that in 2008?
Ensure brevity in your answer.  0.73. What is the difference between the highest and the second highest Emissions(kt) of Euro area?
Keep it short and to the point. 6039.27. What is the difference between the highest and the second highest Emissions(kt) of Upper middle income?
Your answer should be very brief. 2.28e+05. What is the difference between the highest and the second highest Emissions(kt) of Indonesia?
Provide a short and direct response. 4.45e+04. What is the difference between the highest and the lowest Emissions(kt) of Euro area?
Provide a succinct answer. 7.28e+04. What is the difference between the highest and the lowest Emissions(kt) of Upper middle income?
Your answer should be very brief. 2.11e+06. What is the difference between the highest and the lowest Emissions(kt) in Indonesia?
Ensure brevity in your answer.  1.07e+05. What is the difference between the highest and the lowest Emissions(kt) in Sri Lanka?
Ensure brevity in your answer.  69.67. 